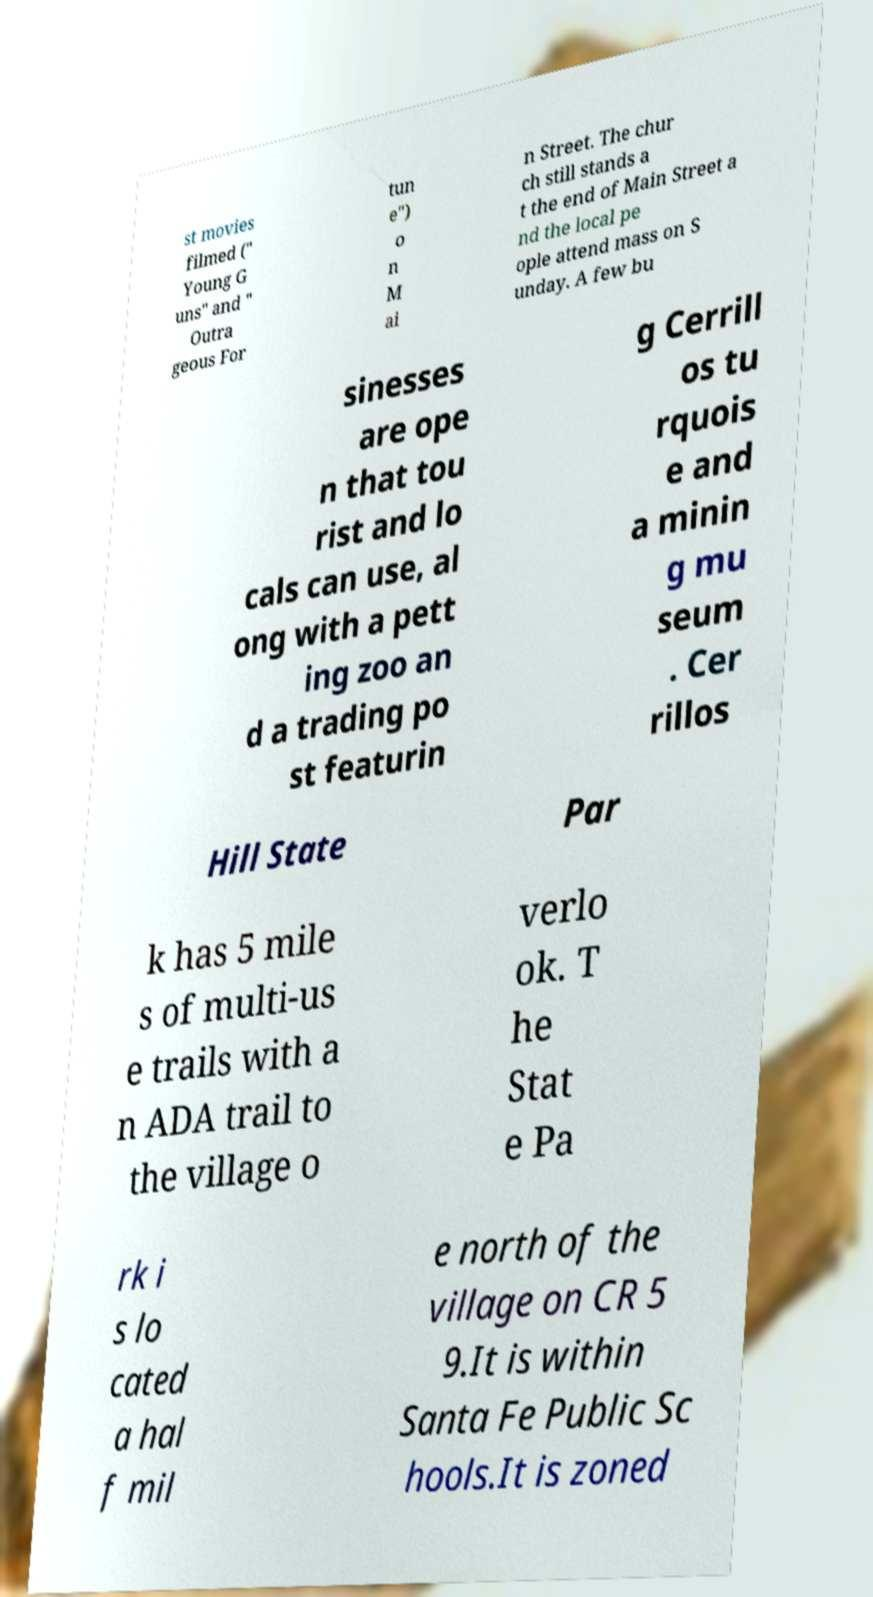Please read and relay the text visible in this image. What does it say? st movies filmed (" Young G uns" and " Outra geous For tun e") o n M ai n Street. The chur ch still stands a t the end of Main Street a nd the local pe ople attend mass on S unday. A few bu sinesses are ope n that tou rist and lo cals can use, al ong with a pett ing zoo an d a trading po st featurin g Cerrill os tu rquois e and a minin g mu seum . Cer rillos Hill State Par k has 5 mile s of multi-us e trails with a n ADA trail to the village o verlo ok. T he Stat e Pa rk i s lo cated a hal f mil e north of the village on CR 5 9.It is within Santa Fe Public Sc hools.It is zoned 